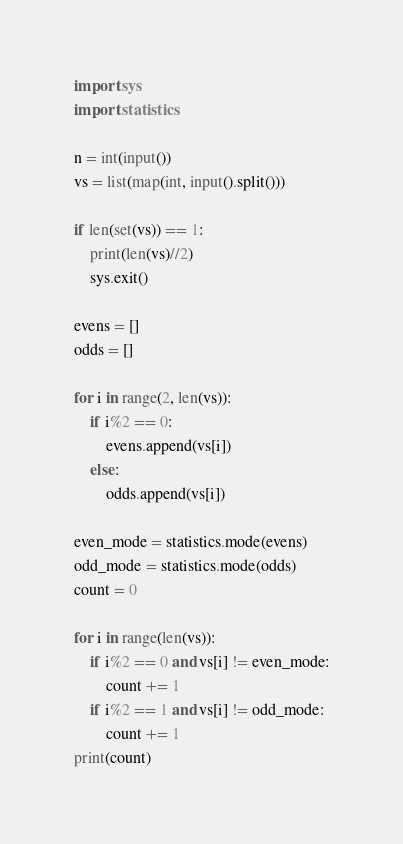<code> <loc_0><loc_0><loc_500><loc_500><_Python_>import sys
import statistics

n = int(input())
vs = list(map(int, input().split()))

if len(set(vs)) == 1:
    print(len(vs)//2)
    sys.exit()

evens = []
odds = []

for i in range(2, len(vs)):
    if i%2 == 0:
        evens.append(vs[i])
    else:
        odds.append(vs[i])

even_mode = statistics.mode(evens)
odd_mode = statistics.mode(odds)
count = 0

for i in range(len(vs)):
    if i%2 == 0 and vs[i] != even_mode:
        count += 1
    if i%2 == 1 and vs[i] != odd_mode:
        count += 1
print(count)</code> 